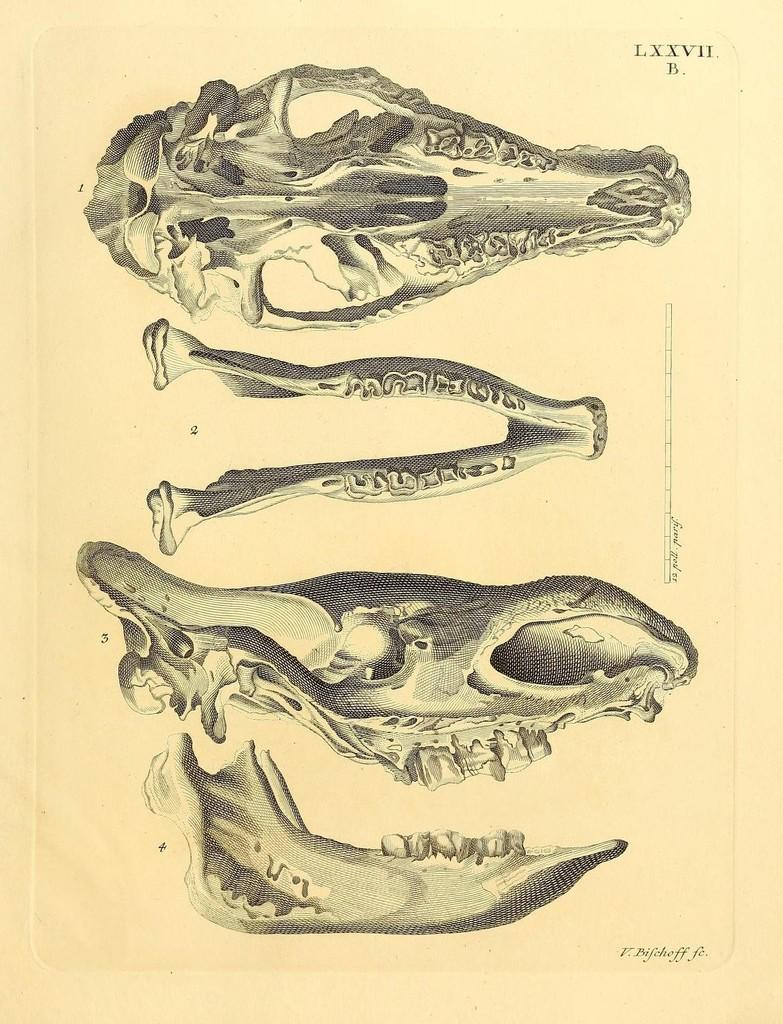Could you give a brief overview of what you see in this image? This image is a drawing. In this image we can see a skulls. 